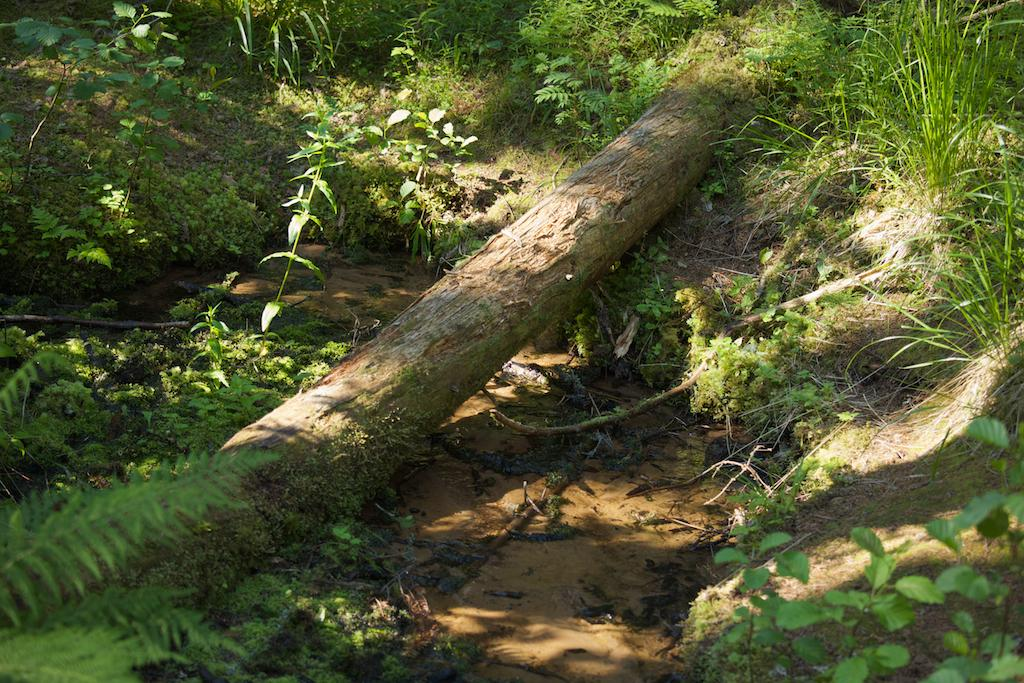What is the main subject in the image? The main subject in the image is the trunk of a tree. What type of vegetation is visible in the image? There is grass and plants visible in the image. What type of brick is used to build the snake's habitat in the image? There is no brick or snake present in the image; it features the trunk of a tree and vegetation. 